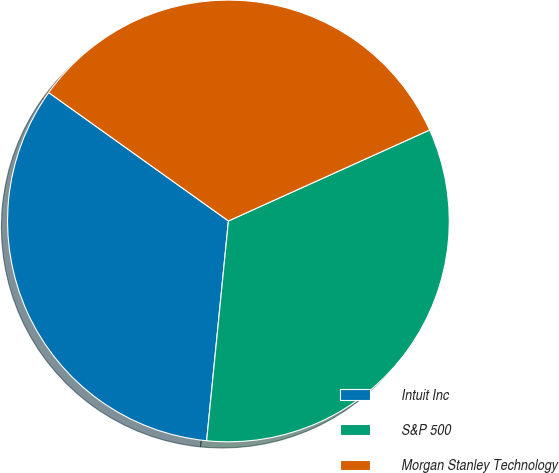<chart> <loc_0><loc_0><loc_500><loc_500><pie_chart><fcel>Intuit Inc<fcel>S&P 500<fcel>Morgan Stanley Technology<nl><fcel>33.3%<fcel>33.33%<fcel>33.37%<nl></chart> 